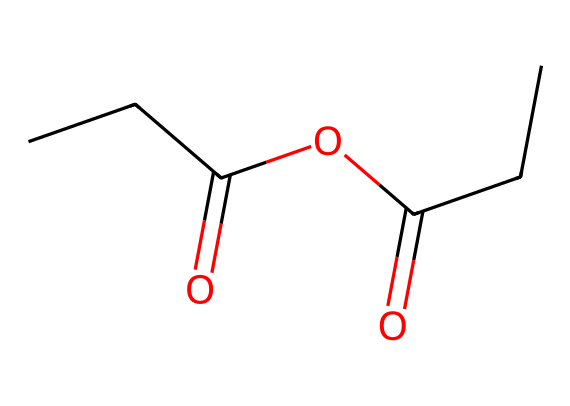how many carbon atoms are in propionic anhydride? In the given SMILES representation, the chain "CCC(=O)OC(=O)CC" indicates there are five "C" atoms present throughout the structure. Each "C" represents a carbon atom.
Answer: five what is the functional group present in propionic anhydride? The structure contains "C(=O)O" functional groups, which indicate the presence of an anhydride. In this case, the anhydride comes from the two carbonyl groups connected by an oxygen atom.
Answer: anhydride how many oxygen atoms are present in this chemical structure? Counting the "O" labels in the SMILES representation reveals there are two oxygen atoms, present as part of the anhydride functional group.
Answer: two what is the primary use of propionic anhydride? Propionic anhydride is primarily used in the production of fabric softeners and fragrances. These applications benefit from its chemical properties that enhance texture and scent.
Answer: fabric softeners and fragrances is propionic anhydride a saturated or unsaturated compound? The chemical structure represented does not contain any double bonds between carbon atoms other than those in the carbonyl groups. Therefore, it can be classified as saturated despite the presence of the carbonyl.
Answer: saturated how does the presence of anhydride groups affect the reactivity of propionic anhydride? Anhydride groups, like those in propionic anhydride, increase reactivity as they can undergo hydrolysis or react with alcohols to form esters. This property is distinct to anhydrides compared to simple carboxylic acids.
Answer: increased reactivity 